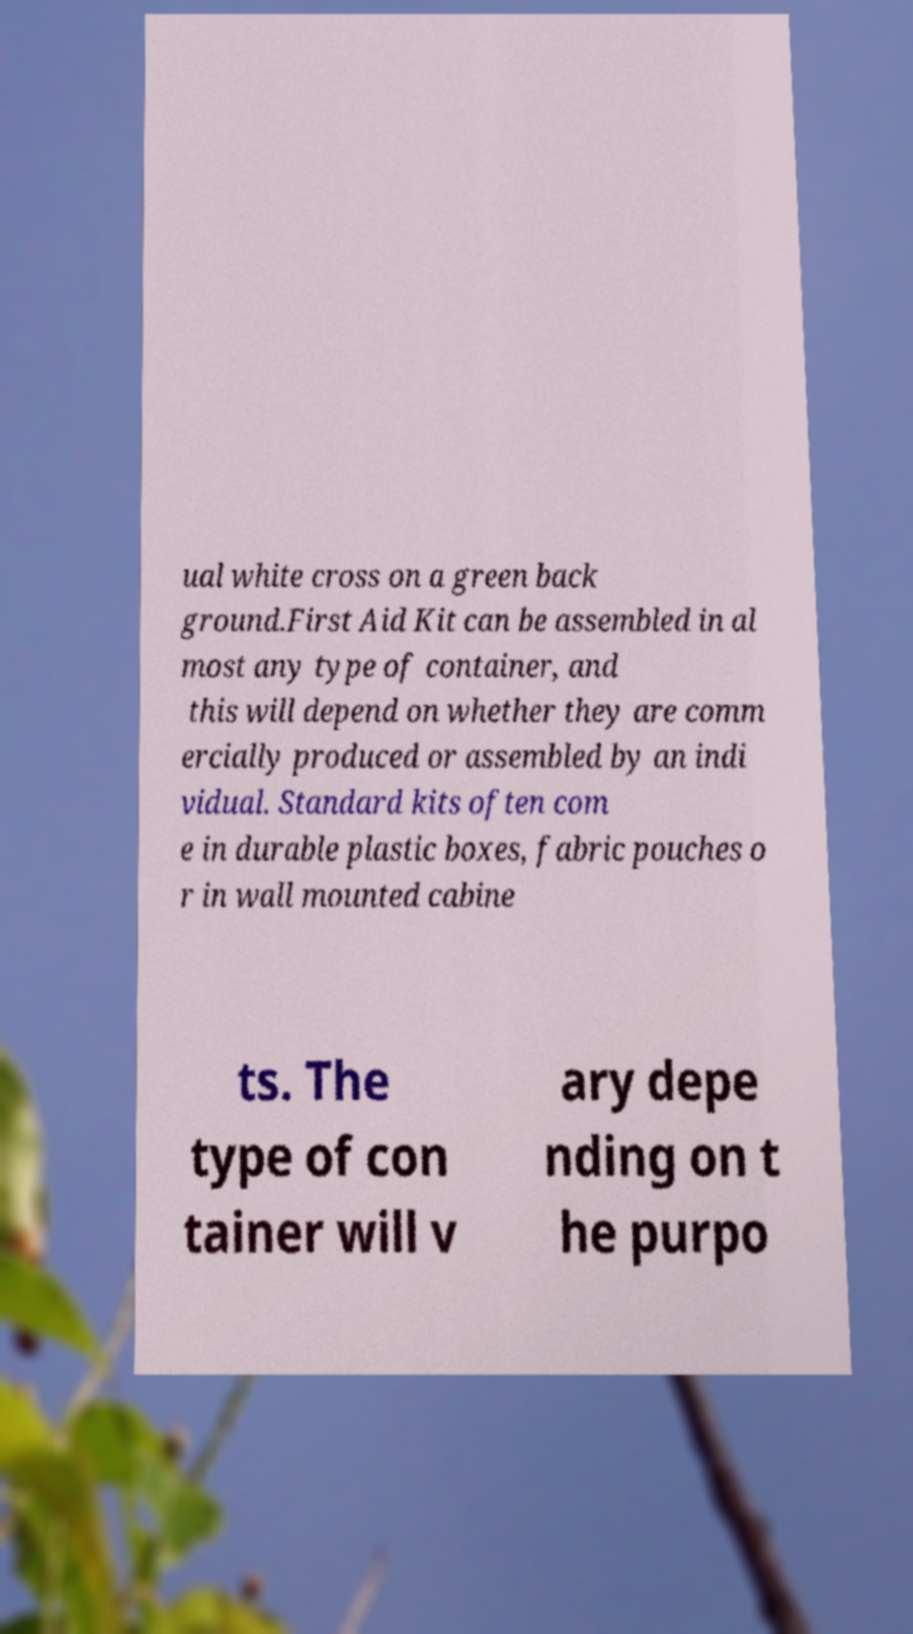For documentation purposes, I need the text within this image transcribed. Could you provide that? ual white cross on a green back ground.First Aid Kit can be assembled in al most any type of container, and this will depend on whether they are comm ercially produced or assembled by an indi vidual. Standard kits often com e in durable plastic boxes, fabric pouches o r in wall mounted cabine ts. The type of con tainer will v ary depe nding on t he purpo 